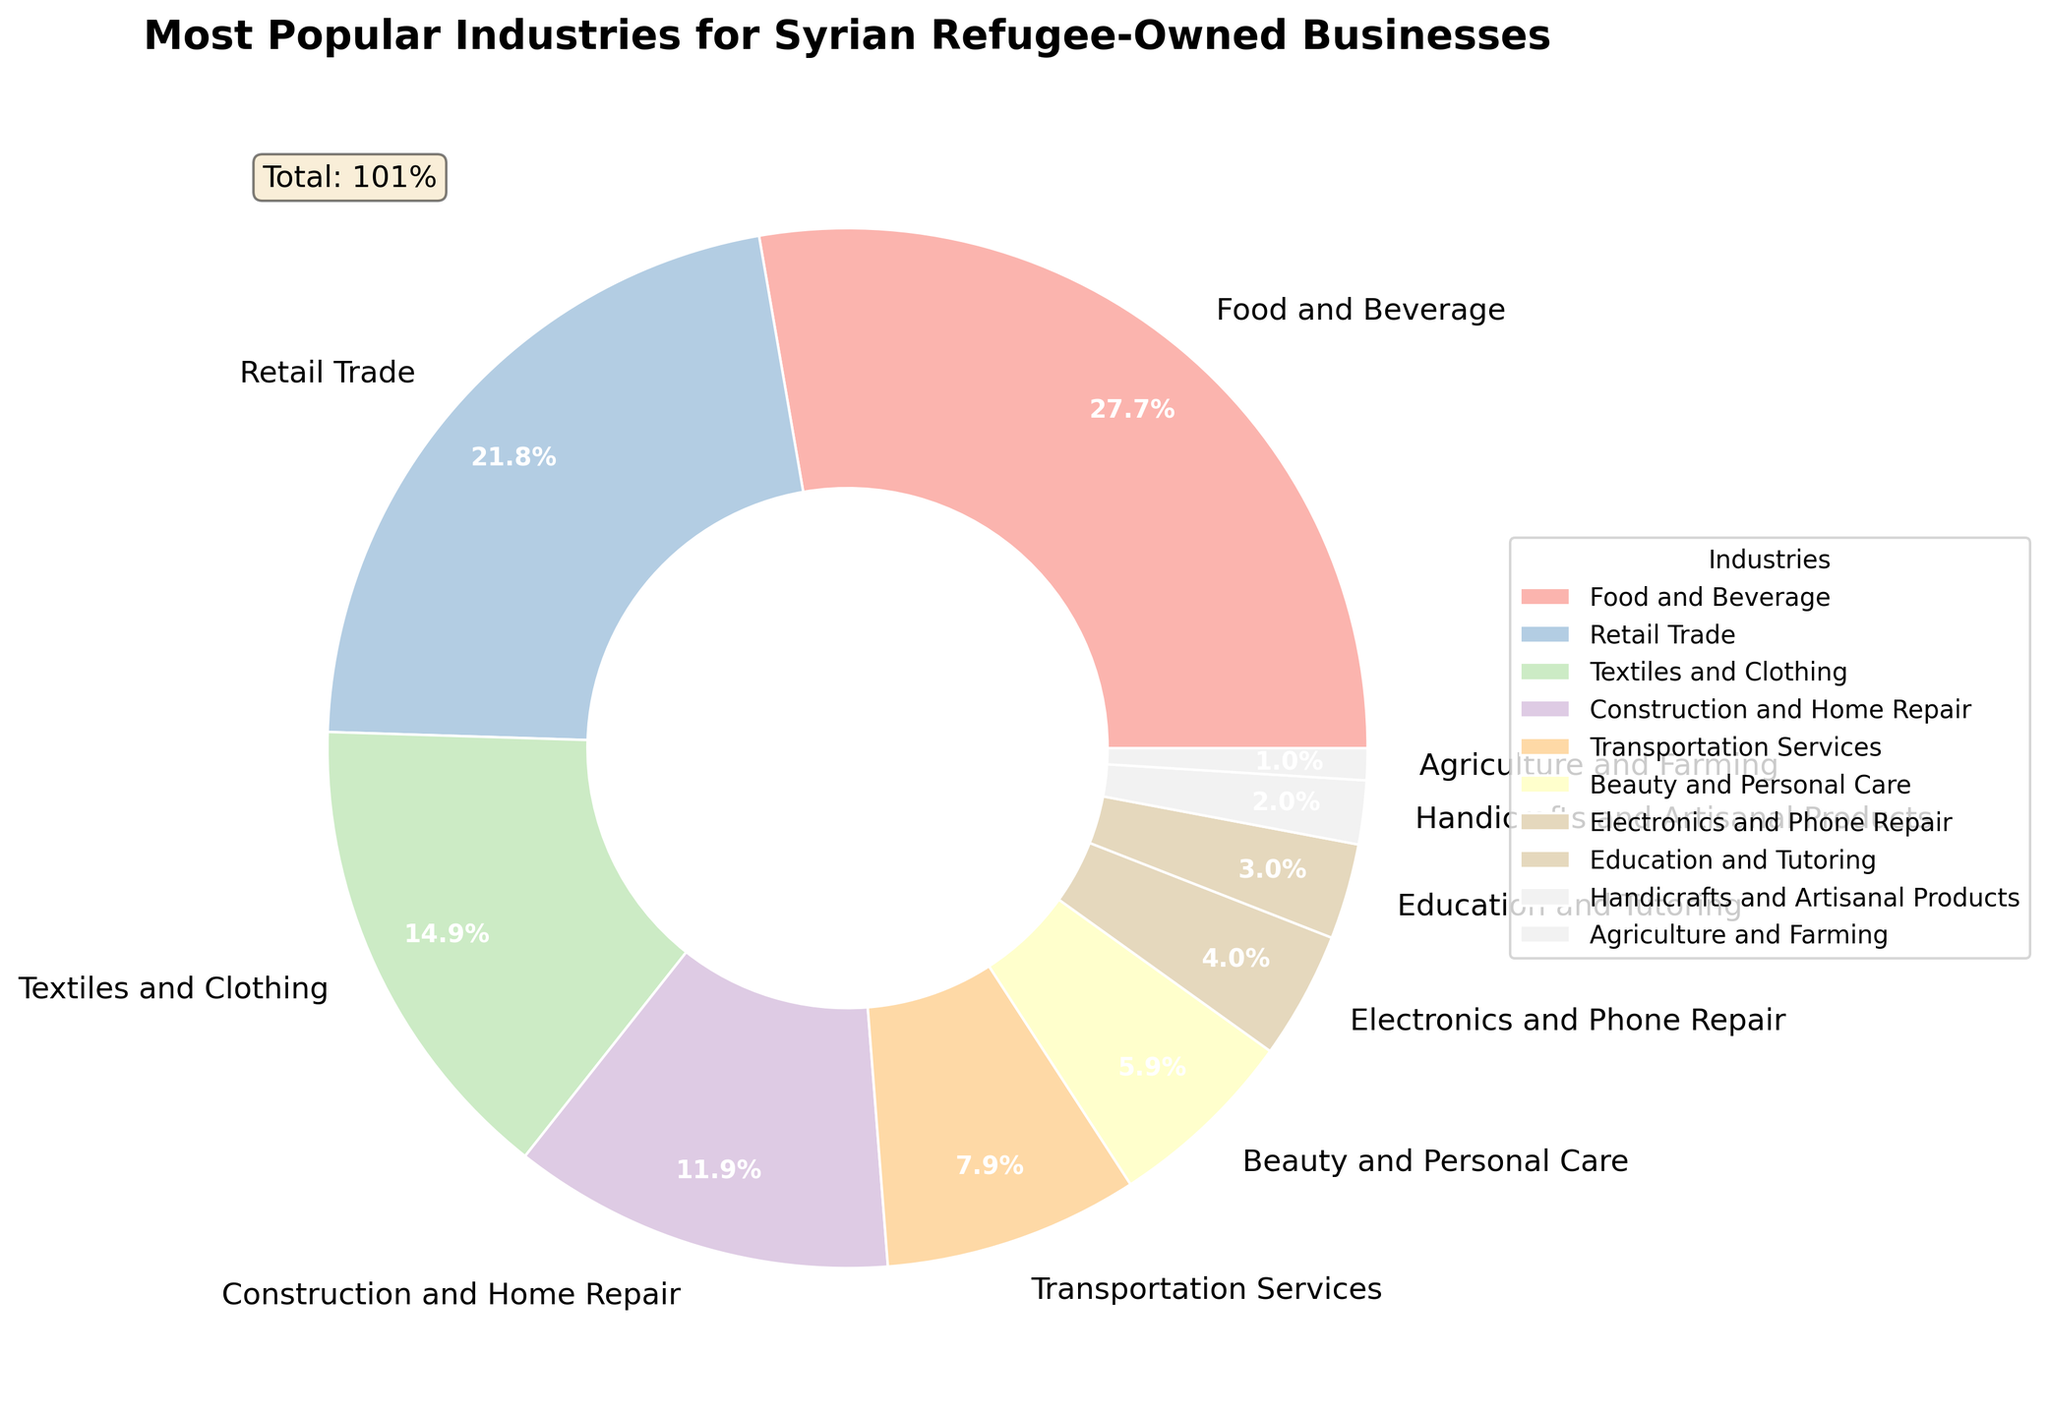Which industry is the most popular for Syrian refugee-owned businesses? The legend and the chart show that Food and Beverage has the highest percentage of 28%.
Answer: Food and Beverage Which industry has a 6% share? By looking at the pie chart and the legend, we see that Beauty and Personal Care has a 6% share.
Answer: Beauty and Personal Care What percentage of the businesses are in Retail Trade and Textiles and Clothing combined? The chart shows that Retail Trade has 22% and Textiles and Clothing has 15%. Adding these together gives 22% + 15% = 37%.
Answer: 37% How does the percentage of Construction and Home Repair compare to that of Textiles and Clothing? Textiles and Clothing has a percentage of 15% while Construction and Home Repair has 12%. Comparing these, Textiles and Clothing has a 3% higher share.
Answer: Textiles and Clothing has 3% more Which industry has the smallest share? The pie chart and legend show that Agriculture and Farming has the smallest share of 1%.
Answer: Agriculture and Farming Is the share of Transportation Services greater than that of Electronics and Phone Repair? According to the chart, Transportation Services has 8%, while Electronics and Phone Repair has 4%. Therefore, Transportation Services has a larger share by 4%.
Answer: Yes, by 4% What is the difference in percentage between Food and Beverage and Education and Tutoring? The chart shows Food and Beverage has a share of 28%, and Education and Tutoring has 3%. The difference is 28% - 3% = 25%.
Answer: 25% What is the total percentage of businesses in Transportation Services, Beauty and Personal Care, and Electronics and Phone Repair? Transportation Services is 8%, Beauty and Personal Care is 6%, and Electronics and Phone Repair is 4%. Adding these together gives 8% + 6% + 4% = 18%.
Answer: 18% Which two industries have the combined percentage of exactly 13%? Checking the chart, we find that Education and Tutoring (3%) and Construction and Home Repair (12%) add up to 15%, and none else sum up to 13%. Therefore, no two industries combine exactly to 13%.
Answer: None How does the share of Handicrafts and Artisanal Products compare visually to that of Construction and Home Repair? Handicrafts and Artisanal Products has a very small sliver in the pie chart representing 2%, whereas Construction and Home Repair has a larger section representing 12%. Hence, Construction and Home Repair occupies a visibly larger portion of the pie chart.
Answer: Construction and Home Repair is visually much larger 